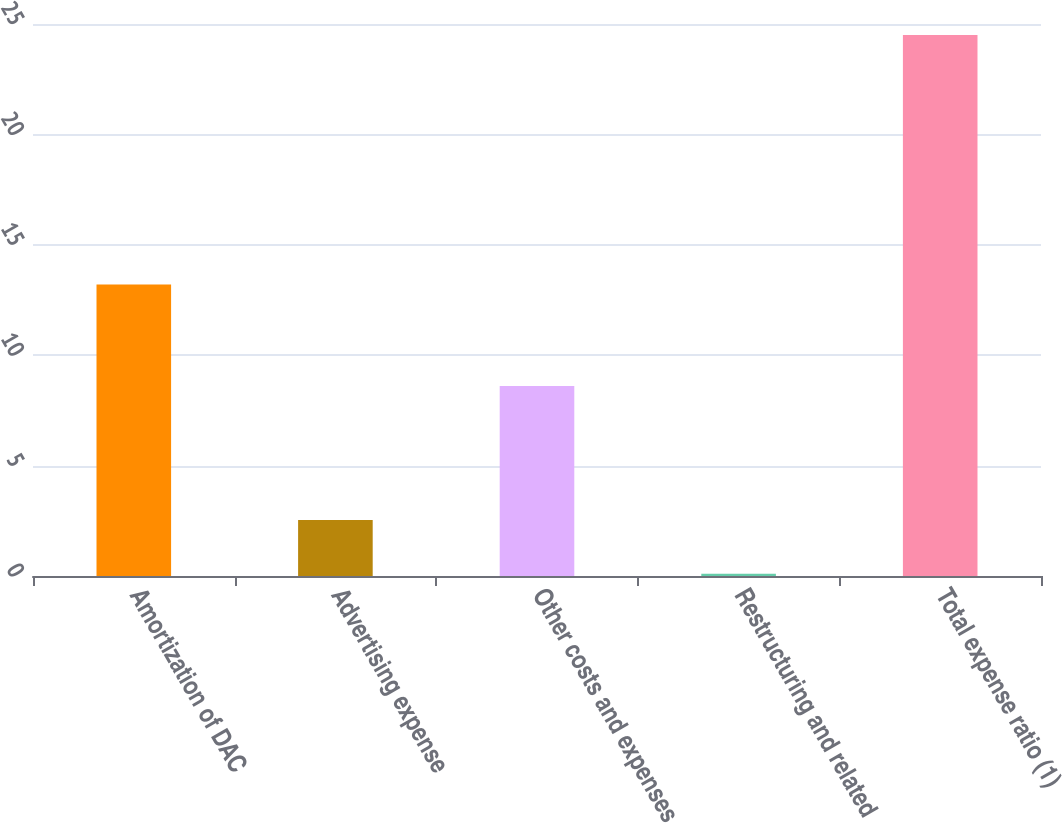Convert chart to OTSL. <chart><loc_0><loc_0><loc_500><loc_500><bar_chart><fcel>Amortization of DAC<fcel>Advertising expense<fcel>Other costs and expenses<fcel>Restructuring and related<fcel>Total expense ratio (1)<nl><fcel>13.2<fcel>2.54<fcel>8.6<fcel>0.1<fcel>24.5<nl></chart> 